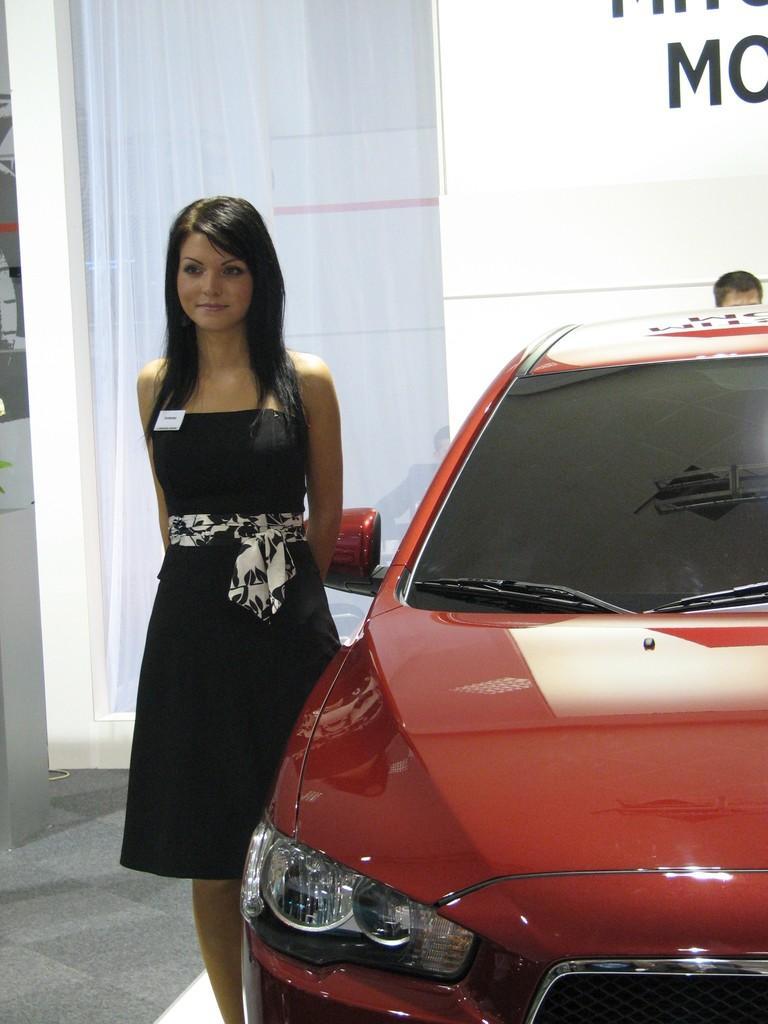Can you describe this image briefly? On the right side of the image we can see a vehicle. Beside the vehicle a woman is standing and smiling. Behind her there is a wall, on the wall there is a curtain. Behind the vehicle a person is standing. 